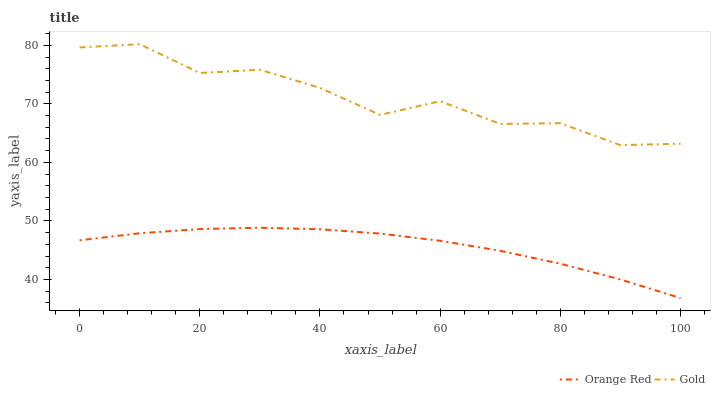Does Gold have the minimum area under the curve?
Answer yes or no. No. Is Gold the smoothest?
Answer yes or no. No. Does Gold have the lowest value?
Answer yes or no. No. Is Orange Red less than Gold?
Answer yes or no. Yes. Is Gold greater than Orange Red?
Answer yes or no. Yes. Does Orange Red intersect Gold?
Answer yes or no. No. 